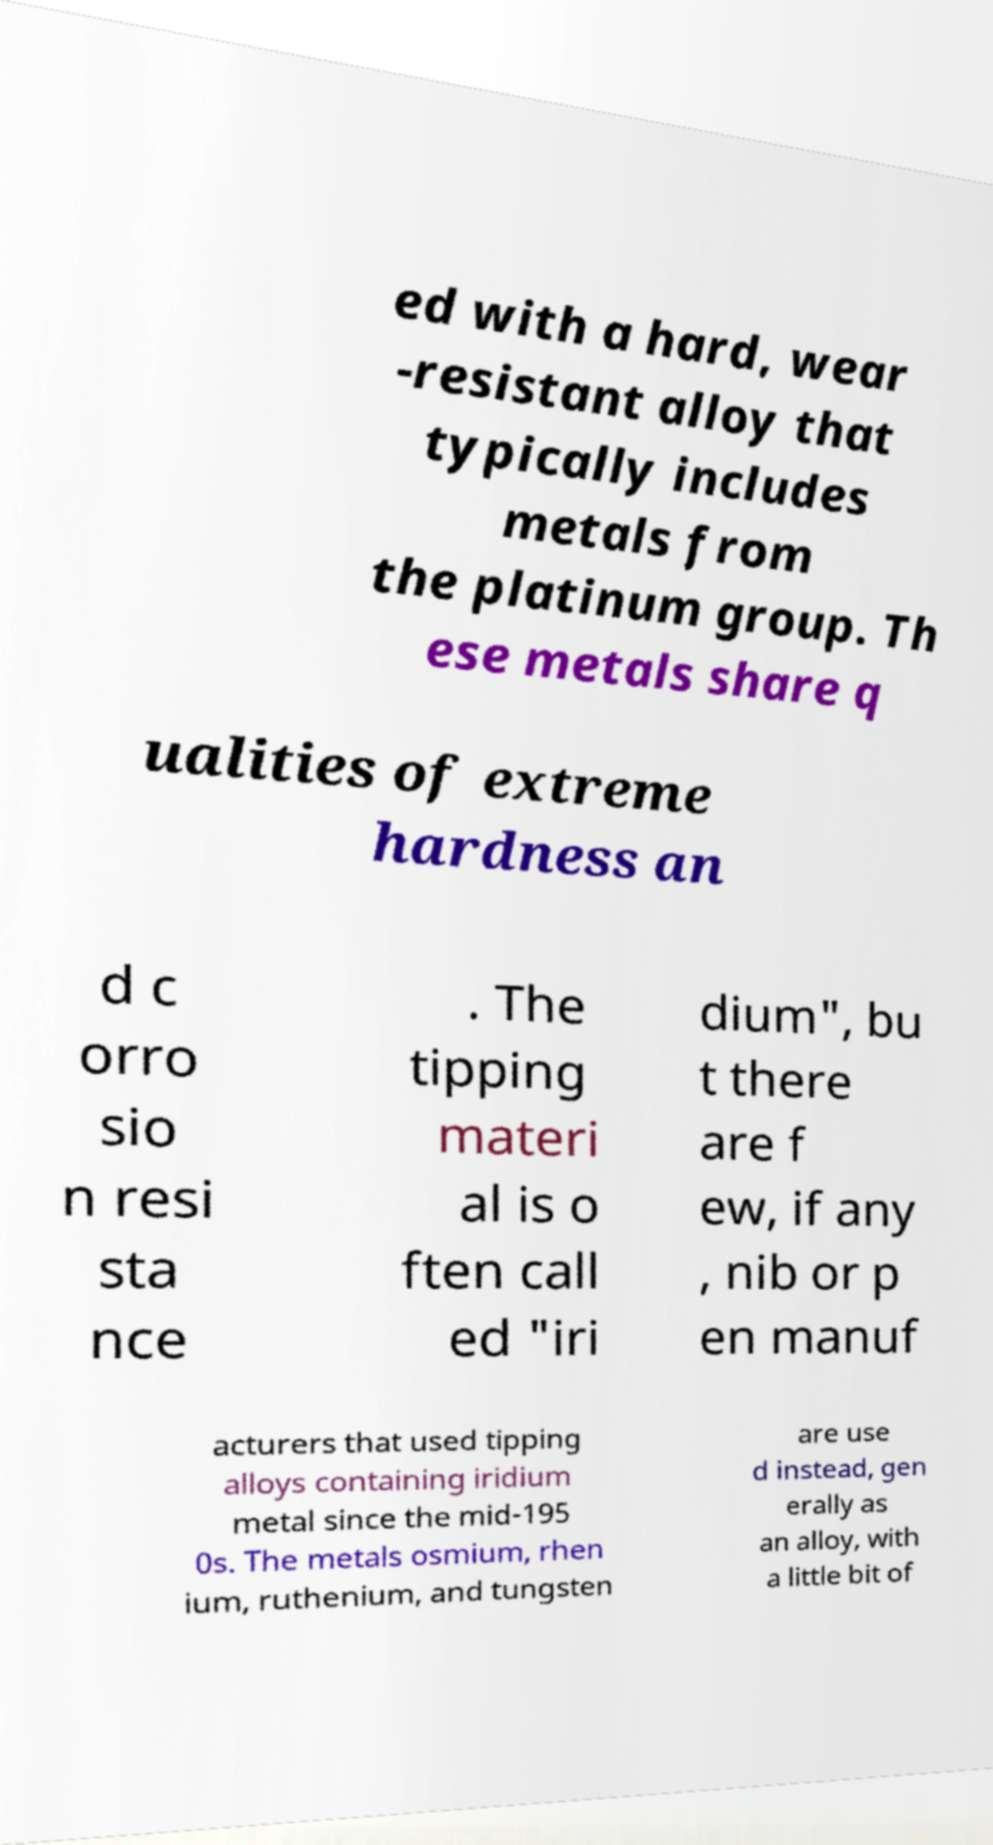Please identify and transcribe the text found in this image. ed with a hard, wear -resistant alloy that typically includes metals from the platinum group. Th ese metals share q ualities of extreme hardness an d c orro sio n resi sta nce . The tipping materi al is o ften call ed "iri dium", bu t there are f ew, if any , nib or p en manuf acturers that used tipping alloys containing iridium metal since the mid-195 0s. The metals osmium, rhen ium, ruthenium, and tungsten are use d instead, gen erally as an alloy, with a little bit of 